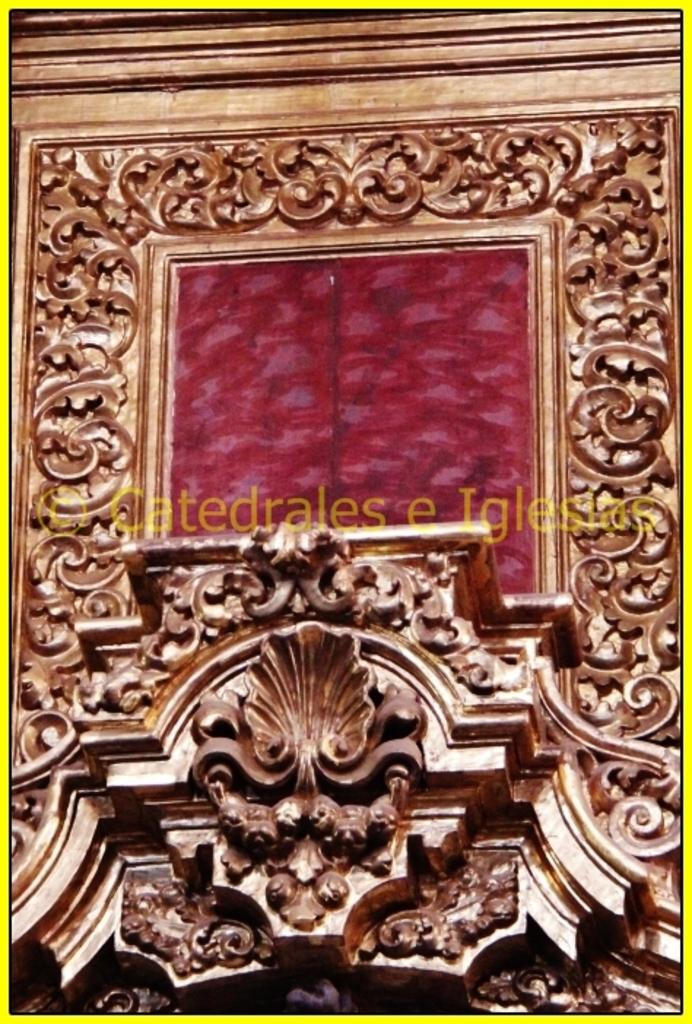Provide a one-sentence caption for the provided image. A gold leaf design frame with a red framed center of a Catedrales e Iglesia. 